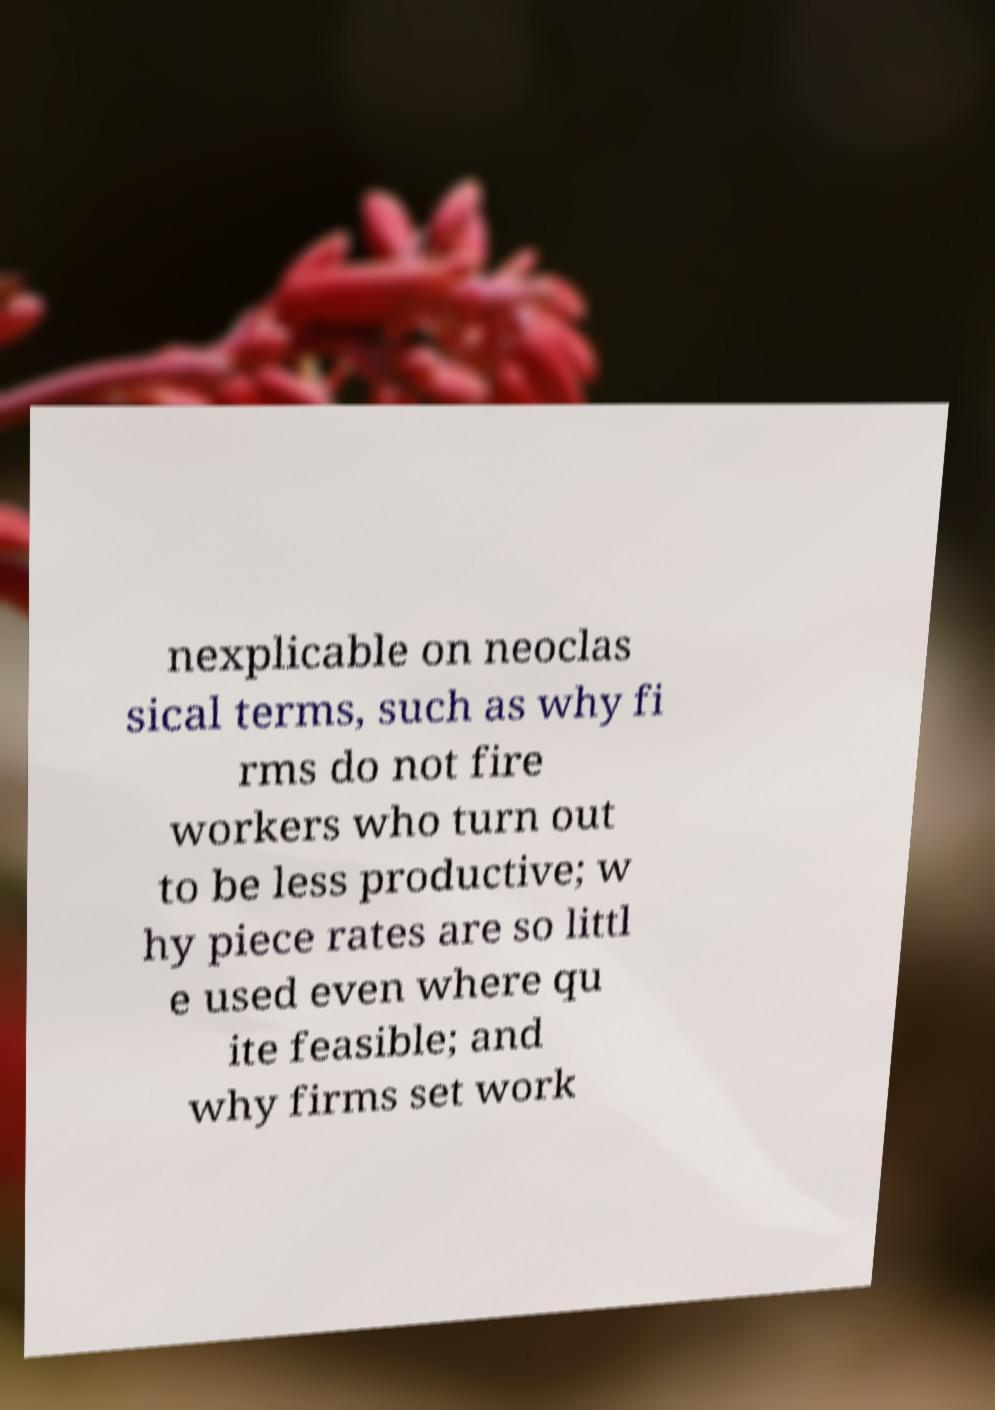Please read and relay the text visible in this image. What does it say? nexplicable on neoclas sical terms, such as why fi rms do not fire workers who turn out to be less productive; w hy piece rates are so littl e used even where qu ite feasible; and why firms set work 